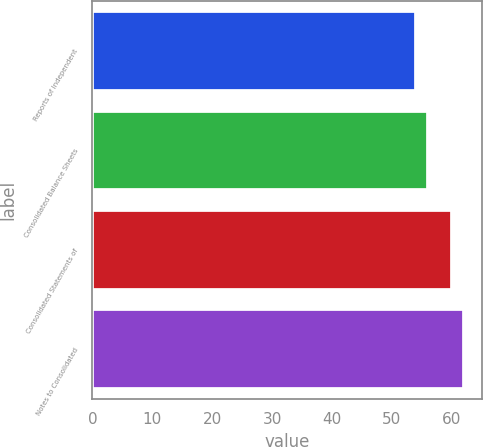<chart> <loc_0><loc_0><loc_500><loc_500><bar_chart><fcel>Reports of Independent<fcel>Consolidated Balance Sheets<fcel>Consolidated Statements of<fcel>Notes to Consolidated<nl><fcel>54<fcel>56<fcel>60<fcel>62<nl></chart> 